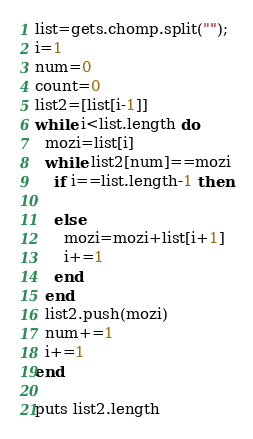Convert code to text. <code><loc_0><loc_0><loc_500><loc_500><_Ruby_>list=gets.chomp.split("");
i=1
num=0
count=0
list2=[list[i-1]]
while i<list.length do
  mozi=list[i]
  while list2[num]==mozi
    if i==list.length-1 then
    
    else
      mozi=mozi+list[i+1]
      i+=1
    end
  end
  list2.push(mozi)
  num+=1
  i+=1
end

puts list2.length</code> 